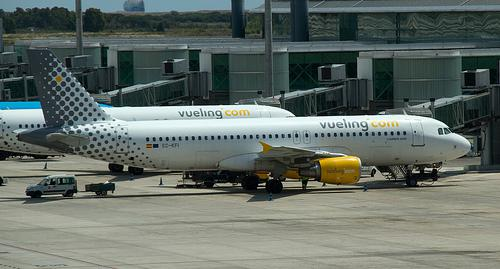Question: what are the planes on?
Choices:
A. The pavement.
B. The runway.
C. Water.
D. Nothing.
Answer with the letter. Answer: A Question: what are the planes made of?
Choices:
A. Metal.
B. Wood.
C. Fiberglass.
D. Glass.
Answer with the letter. Answer: A Question: where was the picture taken?
Choices:
A. At the train station.
B. At the subway.
C. At the bus stop.
D. At the airport.
Answer with the letter. Answer: D 